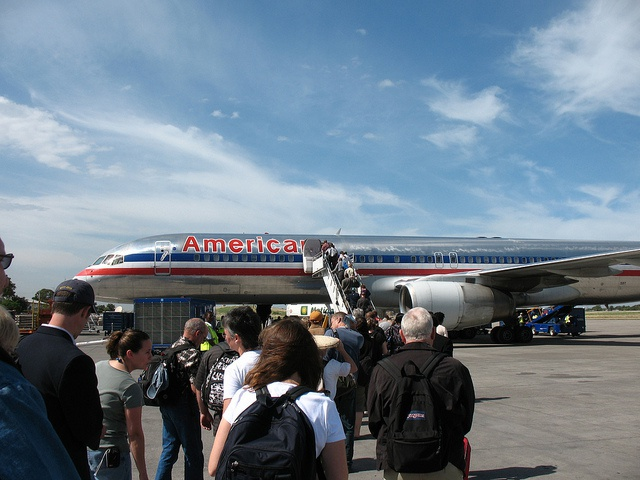Describe the objects in this image and their specific colors. I can see airplane in darkgray, gray, black, and lightgray tones, people in darkgray, black, white, maroon, and gray tones, people in darkgray, black, gray, and maroon tones, people in darkgray, black, and gray tones, and people in darkgray, black, maroon, and gray tones in this image. 